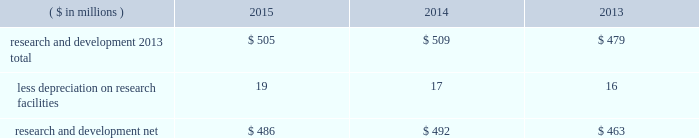38 2015 ppg annual report and form 10-k notes to the consolidated financial statements 1 .
Summary of significant accounting policies principles of consolidation the accompanying consolidated financial statements include the accounts of ppg industries , inc .
( 201cppg 201d or the 201ccompany 201d ) and all subsidiaries , both u.s .
And non-u.s. , that it controls .
Ppg owns more than 50% ( 50 % ) of the voting stock of most of the subsidiaries that it controls .
For those consolidated subsidiaries in which the company 2019s ownership is less than 100% ( 100 % ) , the outside shareholders 2019 interests are shown as noncontrolling interests .
Investments in companies in which ppg owns 20% ( 20 % ) to 50% ( 50 % ) of the voting stock and has the ability to exercise significant influence over operating and financial policies of the investee are accounted for using the equity method of accounting .
As a result , ppg 2019s share of the earnings or losses of such equity affiliates is included in the accompanying consolidated statement of income and ppg 2019s share of these companies 2019 shareholders 2019 equity is included in 201cinvestments 201d in the accompanying consolidated balance sheet .
Transactions between ppg and its subsidiaries are eliminated in consolidation .
Use of estimates in the preparation of financial statements the preparation of financial statements in conformity with u.s .
Generally accepted accounting principles requires management to make estimates and assumptions that affect the reported amounts of assets and liabilities and the disclosure of contingent assets and liabilities at the date of the financial statements , as well as the reported amounts of income and expenses during the reporting period .
Such estimates also include the fair value of assets acquired and liabilities assumed resulting from the allocation of the purchase price related to business combinations consummated .
Actual outcomes could differ from those estimates .
Revenue recognition the company recognizes revenue when the earnings process is complete .
Revenue from sales is recognized by all operating segments when goods are shipped and title to inventory and risk of loss passes to the customer or when services have been rendered .
Shipping and handling costs amounts billed to customers for shipping and handling are reported in 201cnet sales 201d in the accompanying consolidated statement of income .
Shipping and handling costs incurred by the company for the delivery of goods to customers are included in 201ccost of sales , exclusive of depreciation and amortization 201d in the accompanying consolidated statement of income .
Selling , general and administrative costs amounts presented as 201cselling , general and administrative 201d in the accompanying consolidated statement of income are comprised of selling , customer service , distribution and advertising costs , as well as the costs of providing corporate- wide functional support in such areas as finance , law , human resources and planning .
Distribution costs pertain to the movement and storage of finished goods inventory at company- owned and leased warehouses , terminals and other distribution facilities .
Advertising costs advertising costs are expensed as incurred and totaled $ 324 million , $ 297 million and $ 235 million in 2015 , 2014 and 2013 , respectively .
Research and development research and development costs , which consist primarily of employee related costs , are charged to expense as incurred. .
Legal costs legal costs , primarily include costs associated with acquisition and divestiture transactions , general litigation , environmental regulation compliance , patent and trademark protection and other general corporate purposes , are charged to expense as incurred .
Foreign currency translation the functional currency of most significant non-u.s .
Operations is their local currency .
Assets and liabilities of those operations are translated into u.s .
Dollars using year-end exchange rates ; income and expenses are translated using the average exchange rates for the reporting period .
Unrealized foreign currency translation adjustments are deferred in accumulated other comprehensive loss , a separate component of shareholders 2019 equity .
Cash equivalents cash equivalents are highly liquid investments ( valued at cost , which approximates fair value ) acquired with an original maturity of three months or less .
Short-term investments short-term investments are highly liquid , high credit quality investments ( valued at cost plus accrued interest ) that have stated maturities of greater than three months to one year .
The purchases and sales of these investments are classified as investing activities in the consolidated statement of cash flows .
Marketable equity securities the company 2019s investment in marketable equity securities is recorded at fair market value and reported in 201cother current assets 201d and 201cinvestments 201d in the accompanying consolidated balance sheet with changes in fair market value recorded in income for those securities designated as trading securities and in other comprehensive income , net of tax , for those designated as available for sale securities. .
What was the percentage change in research and development 2013 total from 2013 to 2014? 
Computations: ((509 - 479) / 479)
Answer: 0.06263. 